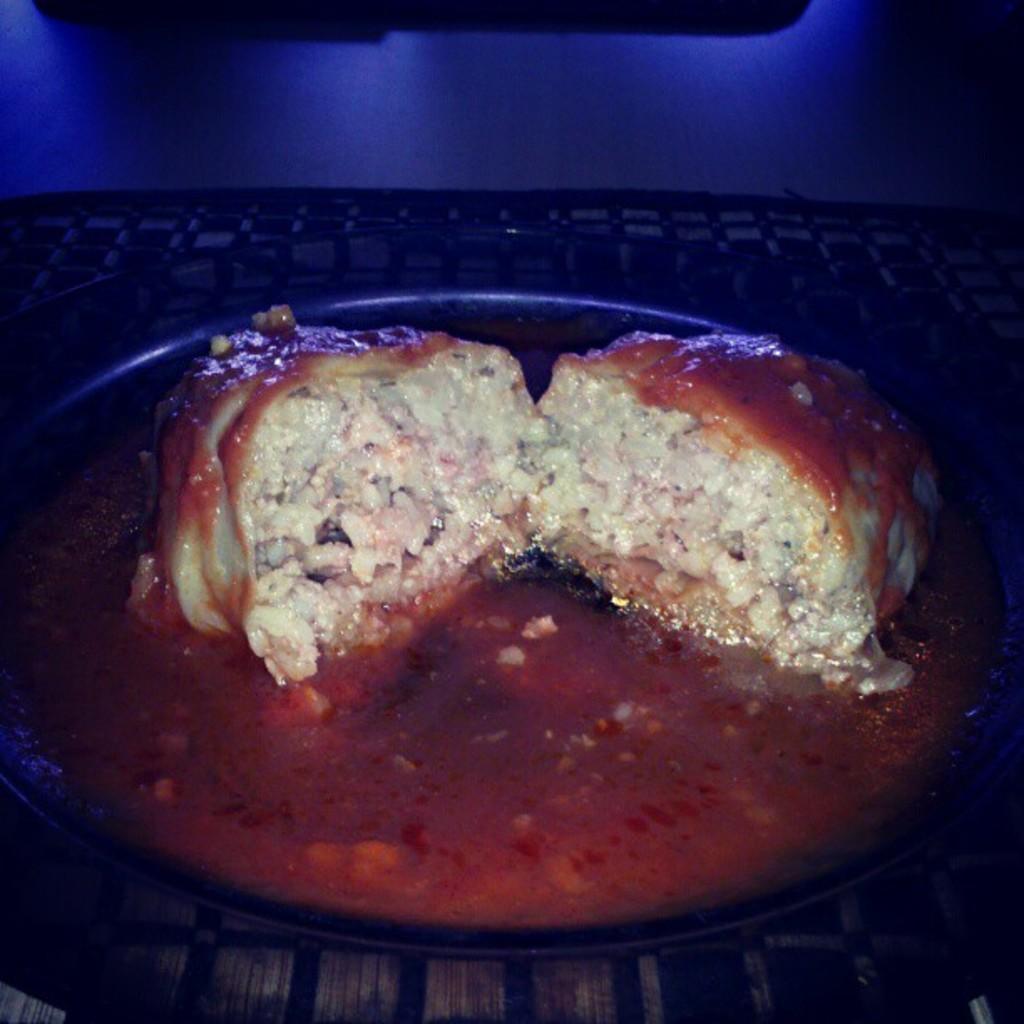Please provide a concise description of this image. This is a food item in a plate. 